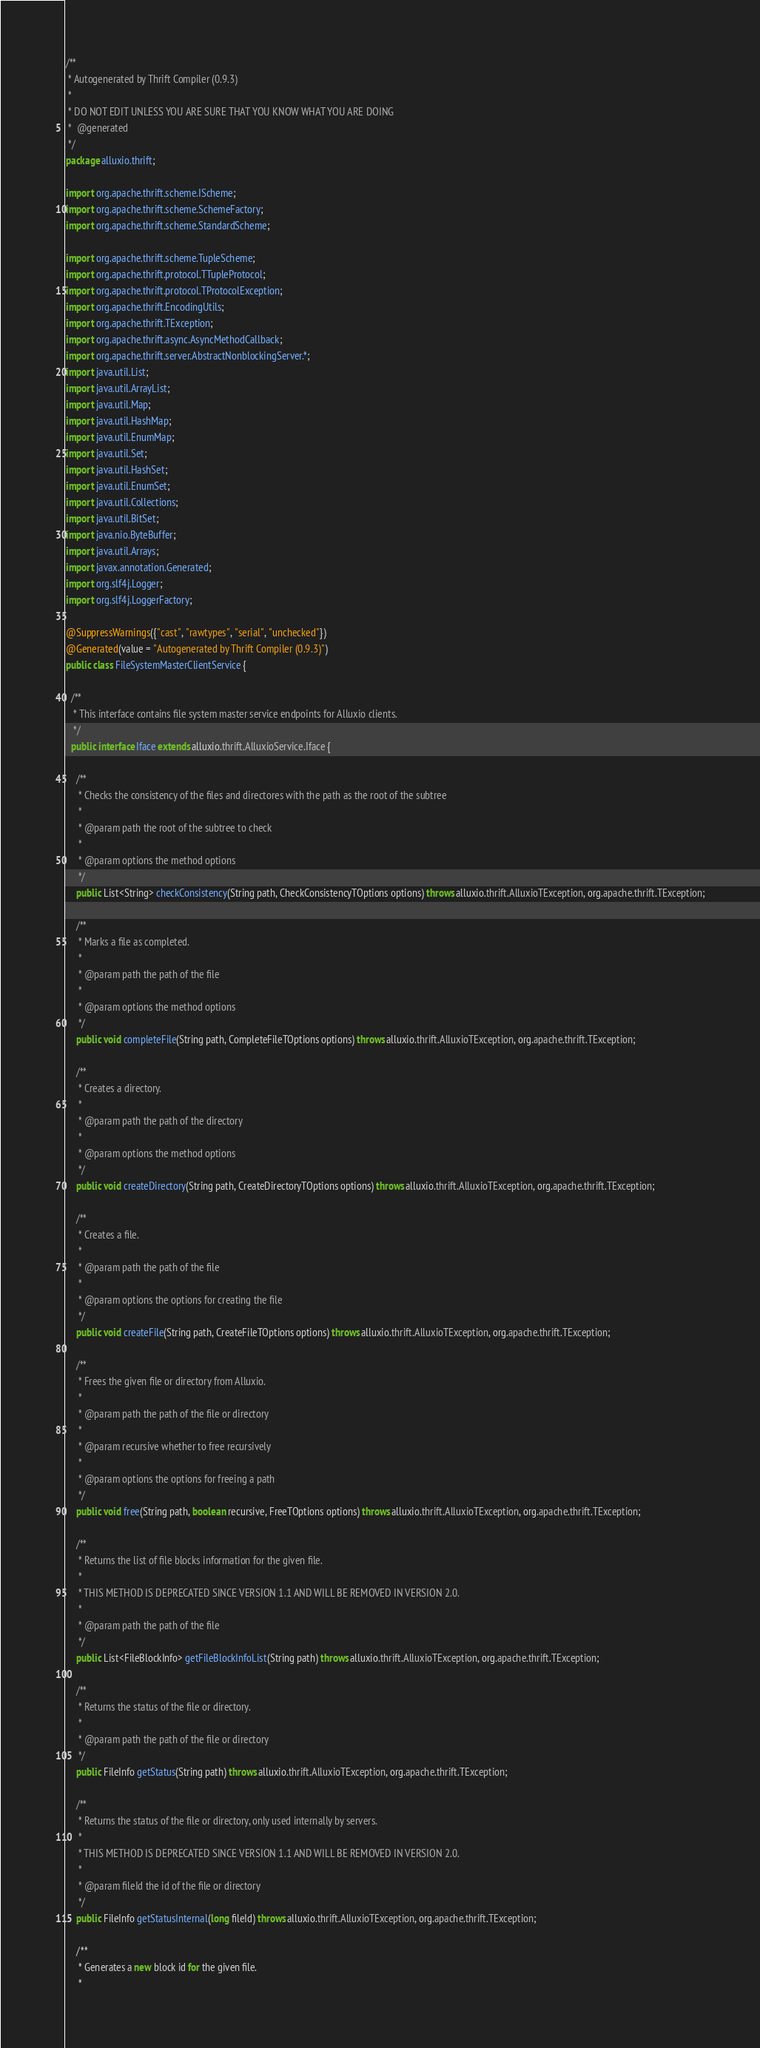Convert code to text. <code><loc_0><loc_0><loc_500><loc_500><_Java_>/**
 * Autogenerated by Thrift Compiler (0.9.3)
 *
 * DO NOT EDIT UNLESS YOU ARE SURE THAT YOU KNOW WHAT YOU ARE DOING
 *  @generated
 */
package alluxio.thrift;

import org.apache.thrift.scheme.IScheme;
import org.apache.thrift.scheme.SchemeFactory;
import org.apache.thrift.scheme.StandardScheme;

import org.apache.thrift.scheme.TupleScheme;
import org.apache.thrift.protocol.TTupleProtocol;
import org.apache.thrift.protocol.TProtocolException;
import org.apache.thrift.EncodingUtils;
import org.apache.thrift.TException;
import org.apache.thrift.async.AsyncMethodCallback;
import org.apache.thrift.server.AbstractNonblockingServer.*;
import java.util.List;
import java.util.ArrayList;
import java.util.Map;
import java.util.HashMap;
import java.util.EnumMap;
import java.util.Set;
import java.util.HashSet;
import java.util.EnumSet;
import java.util.Collections;
import java.util.BitSet;
import java.nio.ByteBuffer;
import java.util.Arrays;
import javax.annotation.Generated;
import org.slf4j.Logger;
import org.slf4j.LoggerFactory;

@SuppressWarnings({"cast", "rawtypes", "serial", "unchecked"})
@Generated(value = "Autogenerated by Thrift Compiler (0.9.3)")
public class FileSystemMasterClientService {

  /**
   * This interface contains file system master service endpoints for Alluxio clients.
   */
  public interface Iface extends alluxio.thrift.AlluxioService.Iface {

    /**
     * Checks the consistency of the files and directores with the path as the root of the subtree
     * 
     * @param path the root of the subtree to check
     * 
     * @param options the method options
     */
    public List<String> checkConsistency(String path, CheckConsistencyTOptions options) throws alluxio.thrift.AlluxioTException, org.apache.thrift.TException;

    /**
     * Marks a file as completed.
     * 
     * @param path the path of the file
     * 
     * @param options the method options
     */
    public void completeFile(String path, CompleteFileTOptions options) throws alluxio.thrift.AlluxioTException, org.apache.thrift.TException;

    /**
     * Creates a directory.
     * 
     * @param path the path of the directory
     * 
     * @param options the method options
     */
    public void createDirectory(String path, CreateDirectoryTOptions options) throws alluxio.thrift.AlluxioTException, org.apache.thrift.TException;

    /**
     * Creates a file.
     * 
     * @param path the path of the file
     * 
     * @param options the options for creating the file
     */
    public void createFile(String path, CreateFileTOptions options) throws alluxio.thrift.AlluxioTException, org.apache.thrift.TException;

    /**
     * Frees the given file or directory from Alluxio.
     * 
     * @param path the path of the file or directory
     * 
     * @param recursive whether to free recursively
     * 
     * @param options the options for freeing a path
     */
    public void free(String path, boolean recursive, FreeTOptions options) throws alluxio.thrift.AlluxioTException, org.apache.thrift.TException;

    /**
     * Returns the list of file blocks information for the given file.
     * 
     * THIS METHOD IS DEPRECATED SINCE VERSION 1.1 AND WILL BE REMOVED IN VERSION 2.0.
     * 
     * @param path the path of the file
     */
    public List<FileBlockInfo> getFileBlockInfoList(String path) throws alluxio.thrift.AlluxioTException, org.apache.thrift.TException;

    /**
     * Returns the status of the file or directory.
     * 
     * @param path the path of the file or directory
     */
    public FileInfo getStatus(String path) throws alluxio.thrift.AlluxioTException, org.apache.thrift.TException;

    /**
     * Returns the status of the file or directory, only used internally by servers.
     * 
     * THIS METHOD IS DEPRECATED SINCE VERSION 1.1 AND WILL BE REMOVED IN VERSION 2.0.
     * 
     * @param fileId the id of the file or directory
     */
    public FileInfo getStatusInternal(long fileId) throws alluxio.thrift.AlluxioTException, org.apache.thrift.TException;

    /**
     * Generates a new block id for the given file.
     * </code> 